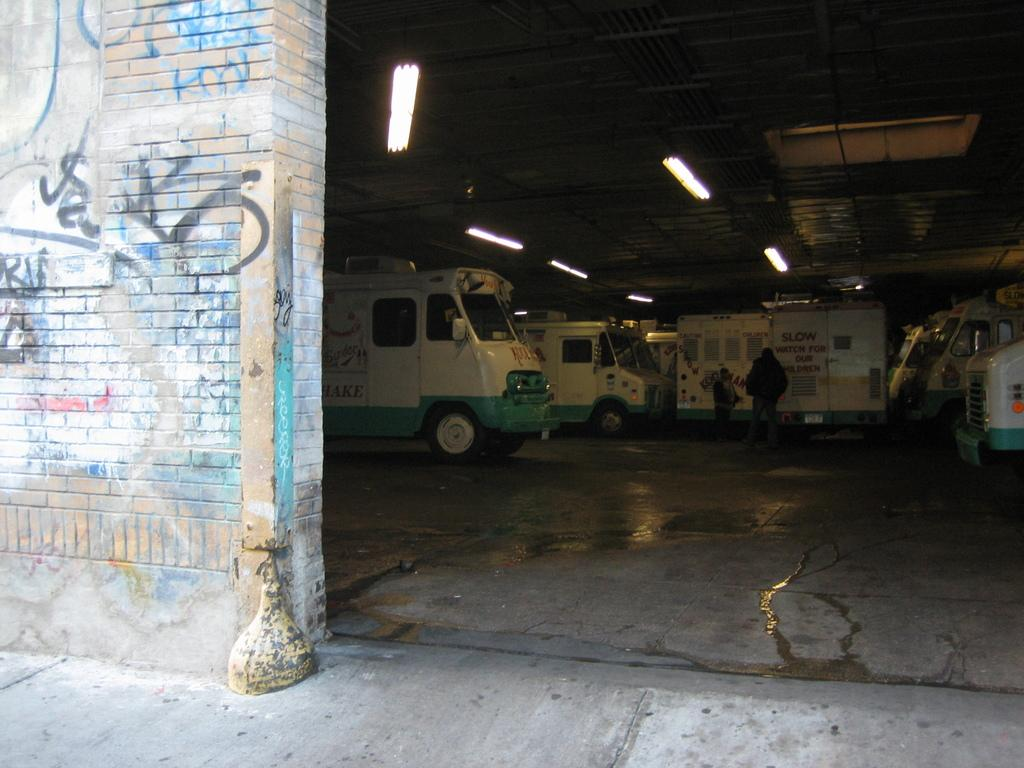What is located on the left side of the image? There is a wall on the left side of the image. What can be seen in the background of the image? There are vehicles and people visible in the background of the image. What is the lighting condition in the image? The image appears to be set in a dark environment, but there are lights visible at the top of the image. What type of sleet can be seen falling in the image? There is no sleet present in the image; it is set in a dark environment with lights visible at the top. Can you describe the eyes of the beetle in the image? There is no beetle present in the image, so its eyes cannot be described. 